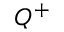<formula> <loc_0><loc_0><loc_500><loc_500>Q ^ { + }</formula> 